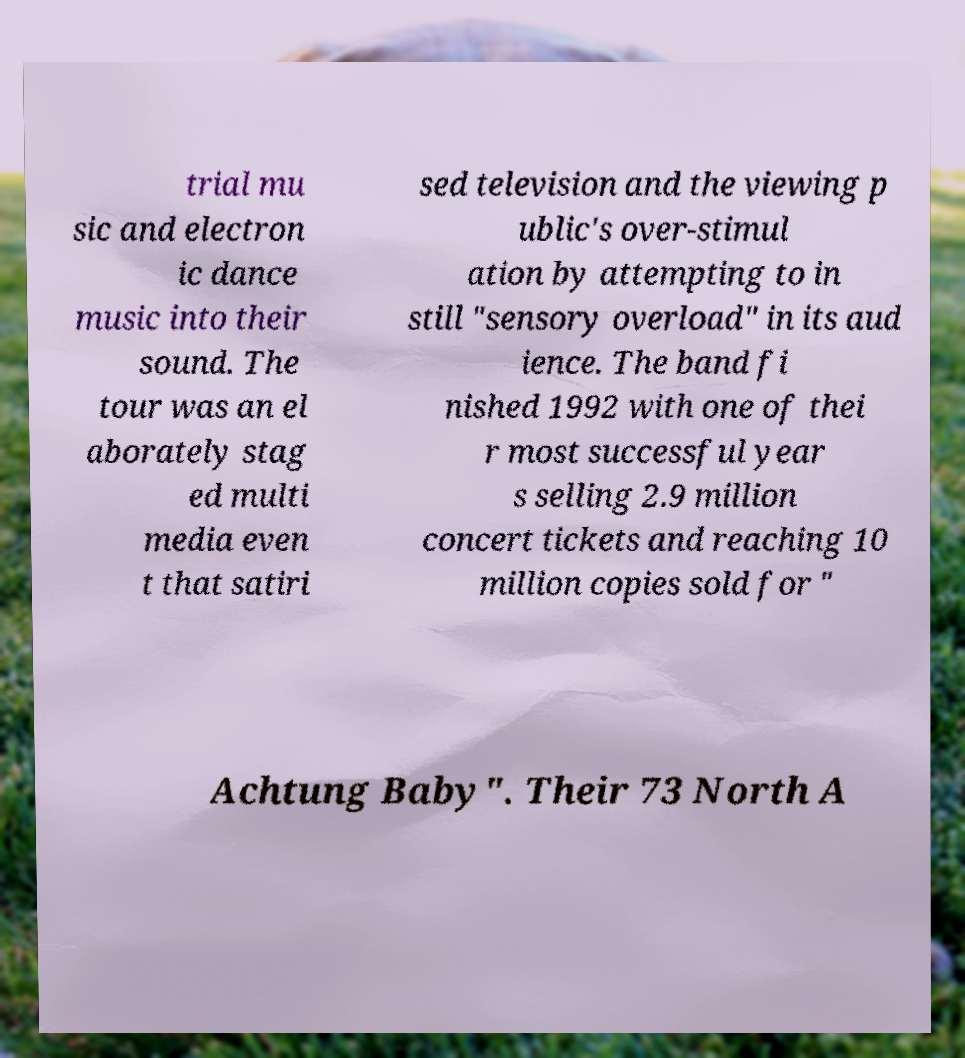Please read and relay the text visible in this image. What does it say? trial mu sic and electron ic dance music into their sound. The tour was an el aborately stag ed multi media even t that satiri sed television and the viewing p ublic's over-stimul ation by attempting to in still "sensory overload" in its aud ience. The band fi nished 1992 with one of thei r most successful year s selling 2.9 million concert tickets and reaching 10 million copies sold for " Achtung Baby". Their 73 North A 